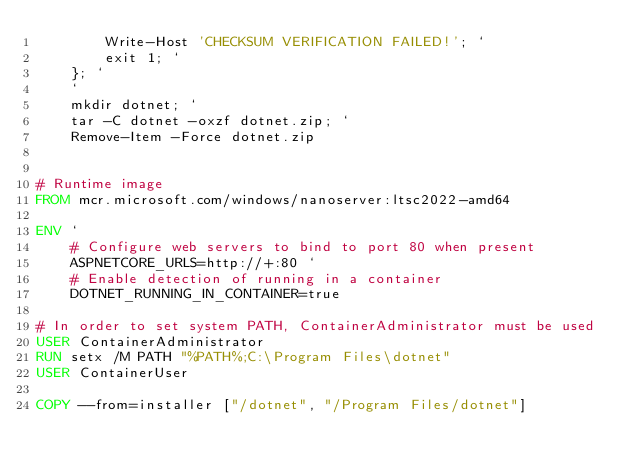<code> <loc_0><loc_0><loc_500><loc_500><_Dockerfile_>        Write-Host 'CHECKSUM VERIFICATION FAILED!'; `
        exit 1; `
    }; `
    `
    mkdir dotnet; `
    tar -C dotnet -oxzf dotnet.zip; `
    Remove-Item -Force dotnet.zip


# Runtime image
FROM mcr.microsoft.com/windows/nanoserver:ltsc2022-amd64

ENV `
    # Configure web servers to bind to port 80 when present
    ASPNETCORE_URLS=http://+:80 `
    # Enable detection of running in a container
    DOTNET_RUNNING_IN_CONTAINER=true

# In order to set system PATH, ContainerAdministrator must be used
USER ContainerAdministrator
RUN setx /M PATH "%PATH%;C:\Program Files\dotnet"
USER ContainerUser

COPY --from=installer ["/dotnet", "/Program Files/dotnet"]
</code> 